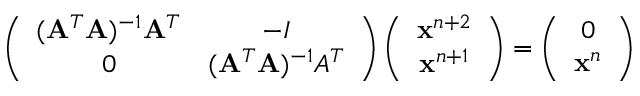Convert formula to latex. <formula><loc_0><loc_0><loc_500><loc_500>\left ( \begin{array} { c c } { ( A ^ { T } A ) ^ { - 1 } A ^ { T } } & { - I } \\ { 0 } & { ( A ^ { T } A ) ^ { - 1 } A ^ { T } } \end{array} \right ) \left ( \begin{array} { c } { x ^ { n + 2 } } \\ { x ^ { n + 1 } } \end{array} \right ) = \left ( \begin{array} { c } { 0 } \\ { x ^ { n } } \end{array} \right )</formula> 